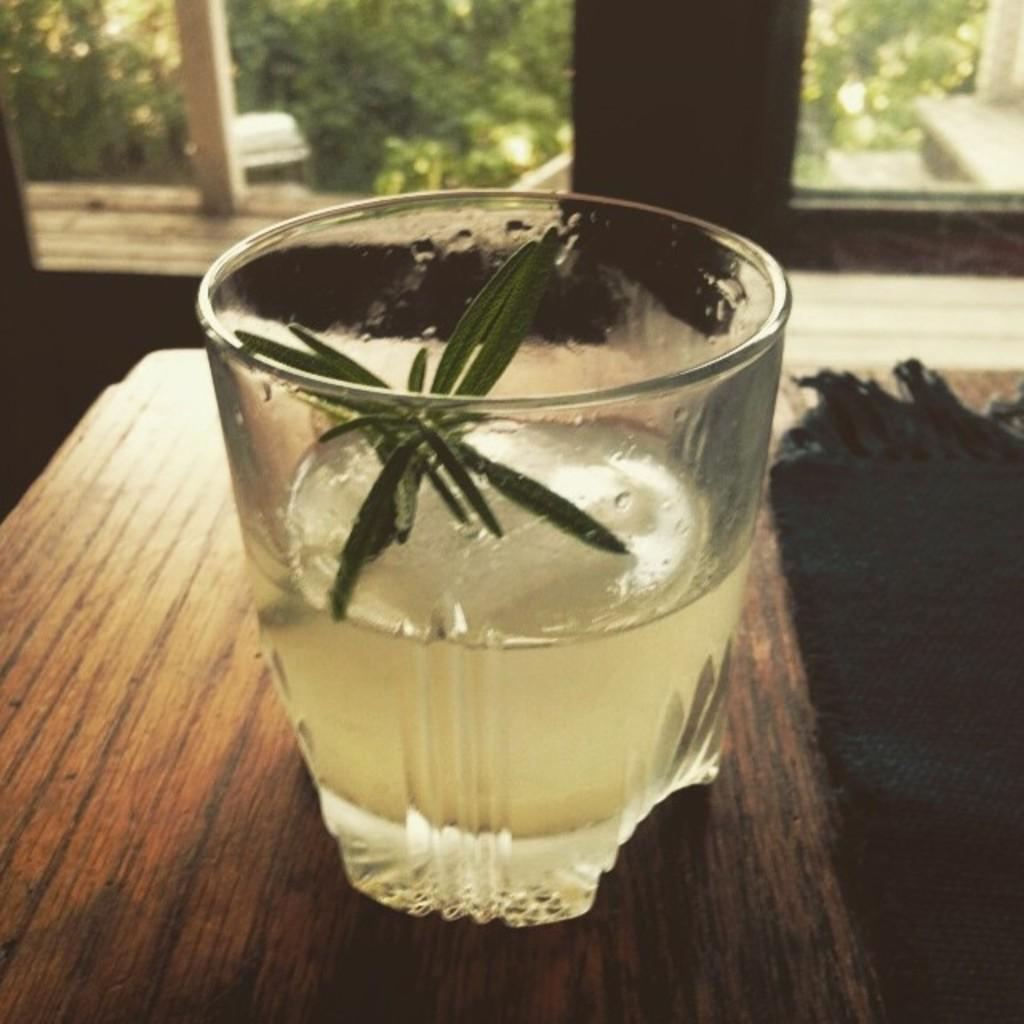What is in the glass that is visible in the image? There is a beverage in a glass in the image. Where is the glass placed in the image? The glass is placed on a table. What can be seen in the background of the image? There are windows and trees visible in the background of the image. How many rings does the person in the image have on their chin? There is no person present in the image, and therefore no rings on their chin can be observed. 